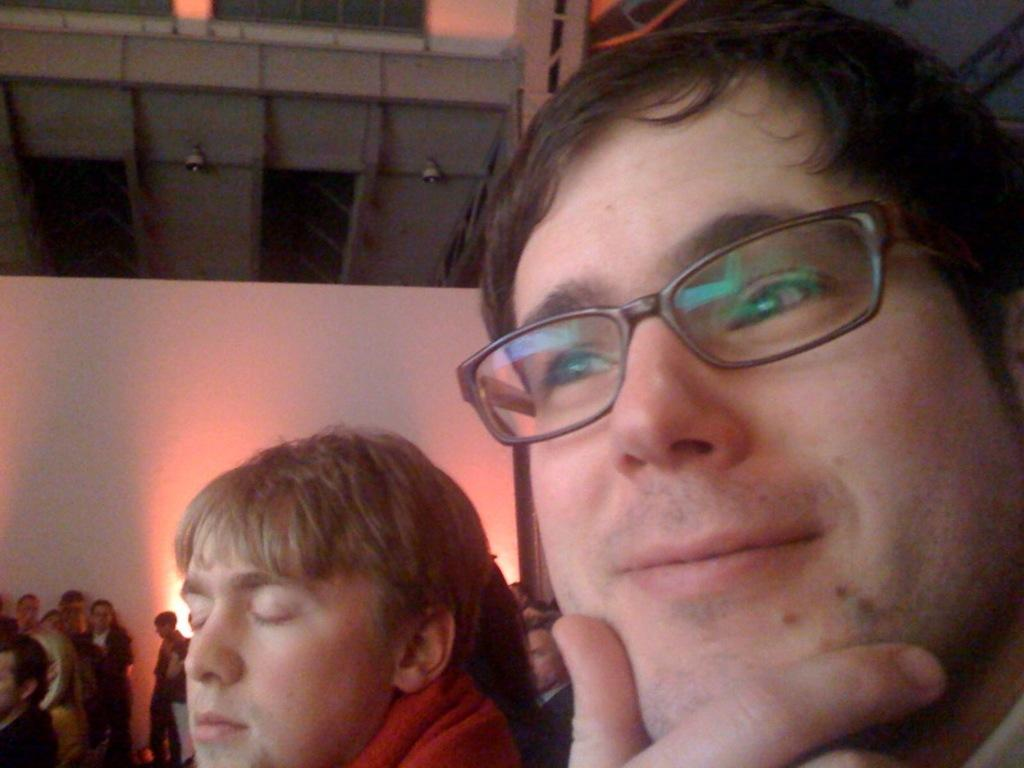How many people are in the image? There is a group of persons in the image, but the exact number cannot be determined from the provided facts. What is behind the persons in the image? There is a wall behind the persons in the image. What is visible towards the top of the image? There is a roof visible towards the top of the image. What can be seen on the roof? There are objects on the roof. How does the stream flow through the image? There is no stream present in the image. What type of spoon is being used by the persons in the image? There is no spoon visible in the image. 